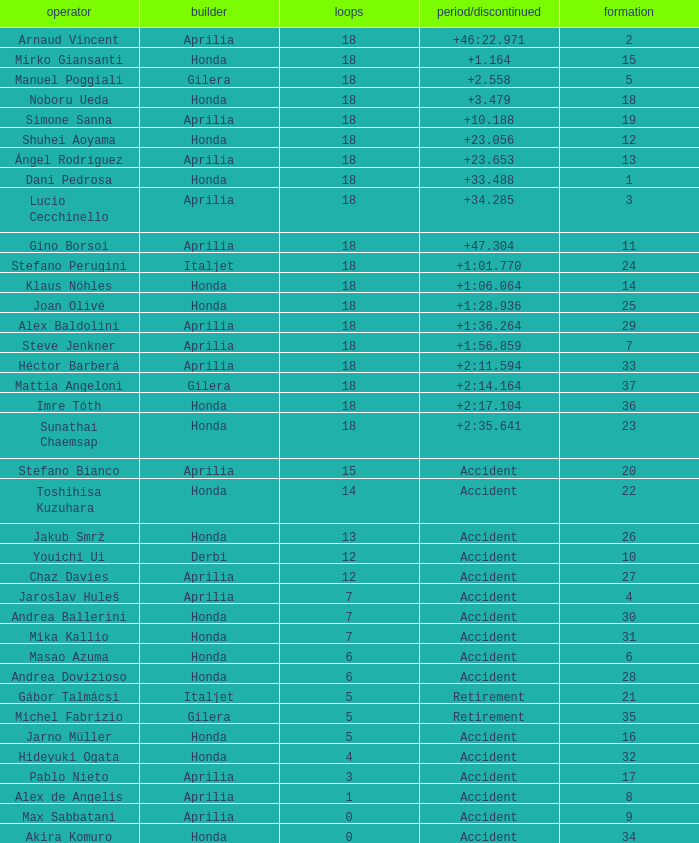What is the average number of laps with an accident time/retired, aprilia manufacturer and a grid of 27? 12.0. 